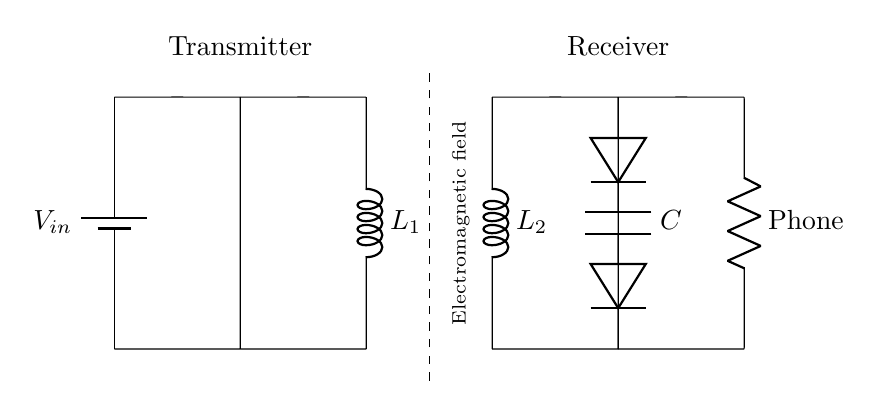What is the input voltage of the circuit? The input voltage, represented as \(V_{in}\), is indicated at the battery in the circuit. It is directly linked to the power supply, showing that it is the source of electrical energy for the circuit.
Answer: V_{in} What type of coil is situated in the transmitter section? The transmitter section includes an inductor labeled as \(L_1\). Inductors are typically marked with "L" in circuit diagrams, indicating they are used for storing energy in a magnetic field.
Answer: L_1 How many diodes are present in the receiver part of the circuit? The receiver part features two diodes arranged in series, functioning to rectify the alternating current induced in the receiver coil \(L_2\) into direct current for use by the load.
Answer: 2 What is the purpose of the smoothing capacitor in the circuit? The smoothing capacitor, labeled as \(C\), is essential for stabilizing the output voltage by reducing ripple voltage after rectification. This component filters out fluctuations to provide a smoother DC voltage to the load.
Answer: Stabilization What happens in the air gap between the transmitter and receiver coils? The air gap is significant as it allows for the creation of an electromagnetic field by the transmitter coil. This field induces current in the receiver coil, demonstrating the principle of electromagnetic induction used in wireless charging.
Answer: Electromagnetic field Which component represents the load in the circuit? The load in the circuit is represented by the resistor labeled as "Phone", indicating the smartphone receiving the charge, as it draws power from the output of the receiver circuit.
Answer: Phone How does the energy transfer occur between the transmitter and receiver coils? Energy transfer occurs through the principle of electromagnetic induction, as the alternating current in the transmitter coil generates a magnetic field that induces an alternating current in the receiver coil located within that field, allowing power to be transferred wirelessly.
Answer: Induction 